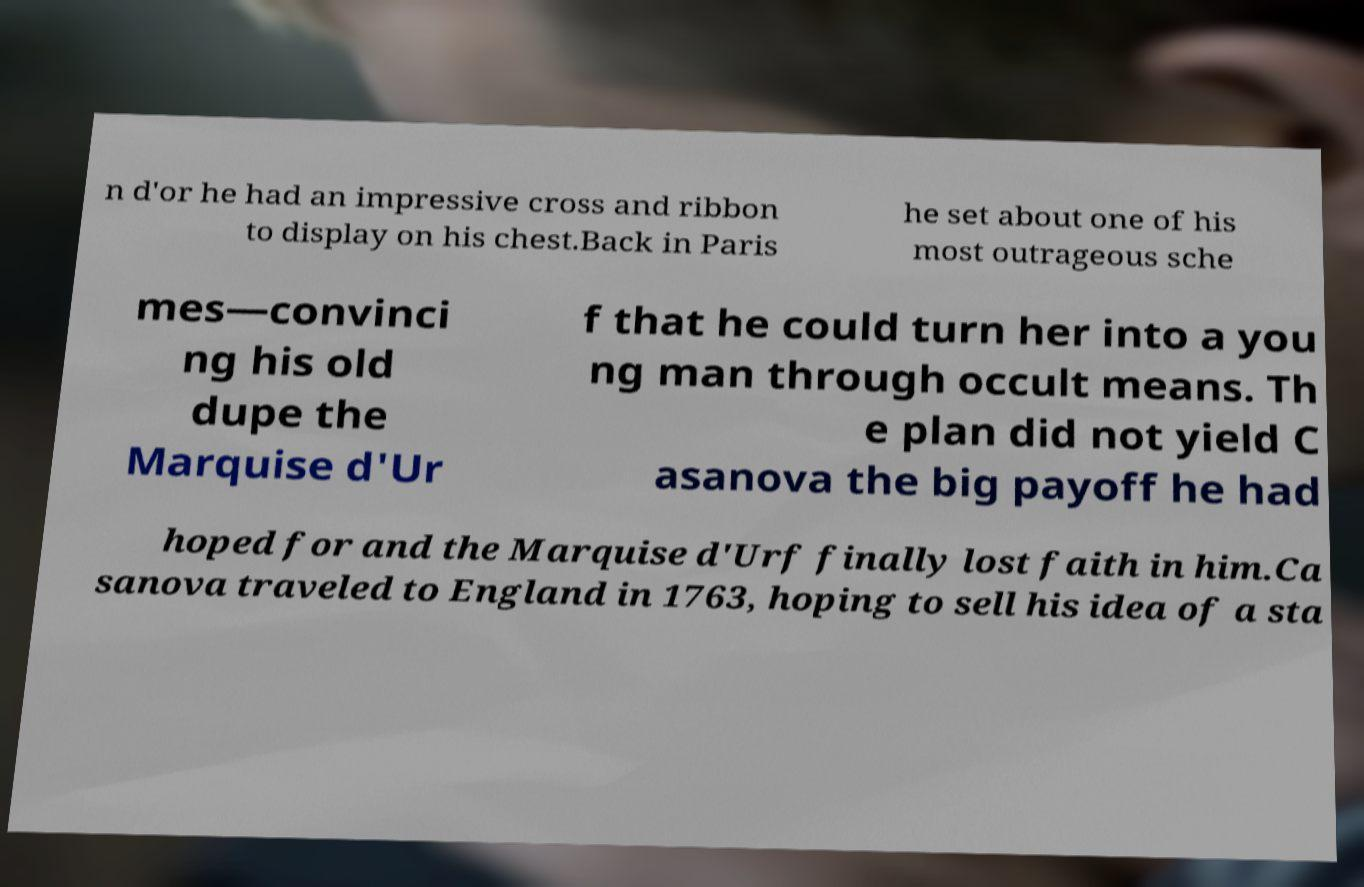Please read and relay the text visible in this image. What does it say? n d'or he had an impressive cross and ribbon to display on his chest.Back in Paris he set about one of his most outrageous sche mes—convinci ng his old dupe the Marquise d'Ur f that he could turn her into a you ng man through occult means. Th e plan did not yield C asanova the big payoff he had hoped for and the Marquise d'Urf finally lost faith in him.Ca sanova traveled to England in 1763, hoping to sell his idea of a sta 